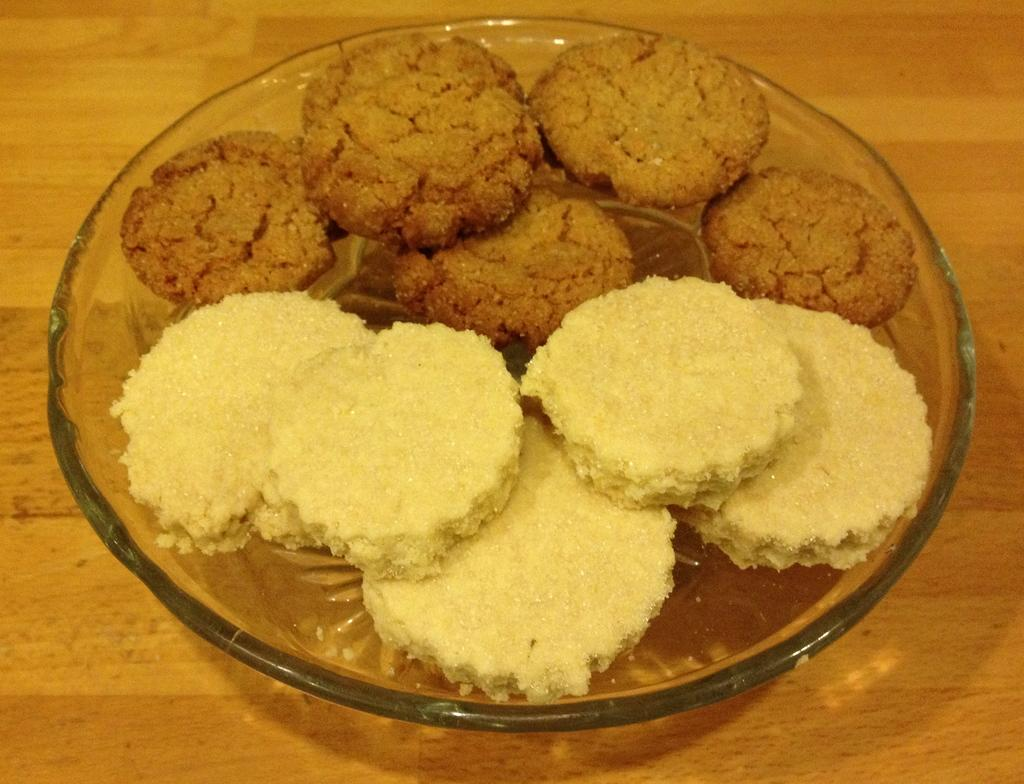What is in the center of the image? There is a plate in the center of the image. What is on the plate? There are cookies on the plate. What piece of furniture is visible in the image? There is a table in the image. What type of earth can be seen in the image? There is no earth or soil visible in the image; it features a plate with cookies on a table. 